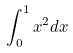<formula> <loc_0><loc_0><loc_500><loc_500>\int _ { 0 } ^ { 1 } x ^ { 2 } d x</formula> 